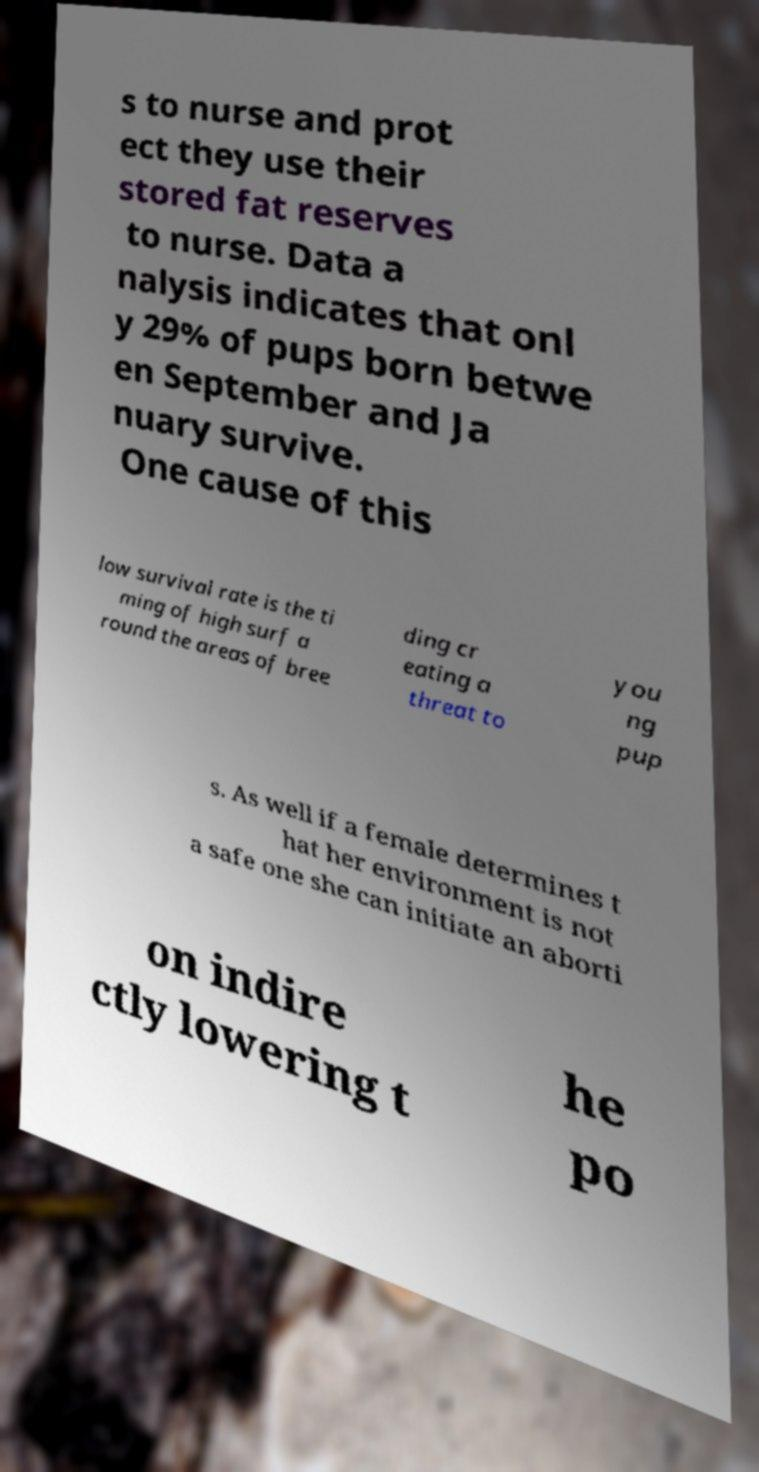Please read and relay the text visible in this image. What does it say? s to nurse and prot ect they use their stored fat reserves to nurse. Data a nalysis indicates that onl y 29% of pups born betwe en September and Ja nuary survive. One cause of this low survival rate is the ti ming of high surf a round the areas of bree ding cr eating a threat to you ng pup s. As well if a female determines t hat her environment is not a safe one she can initiate an aborti on indire ctly lowering t he po 